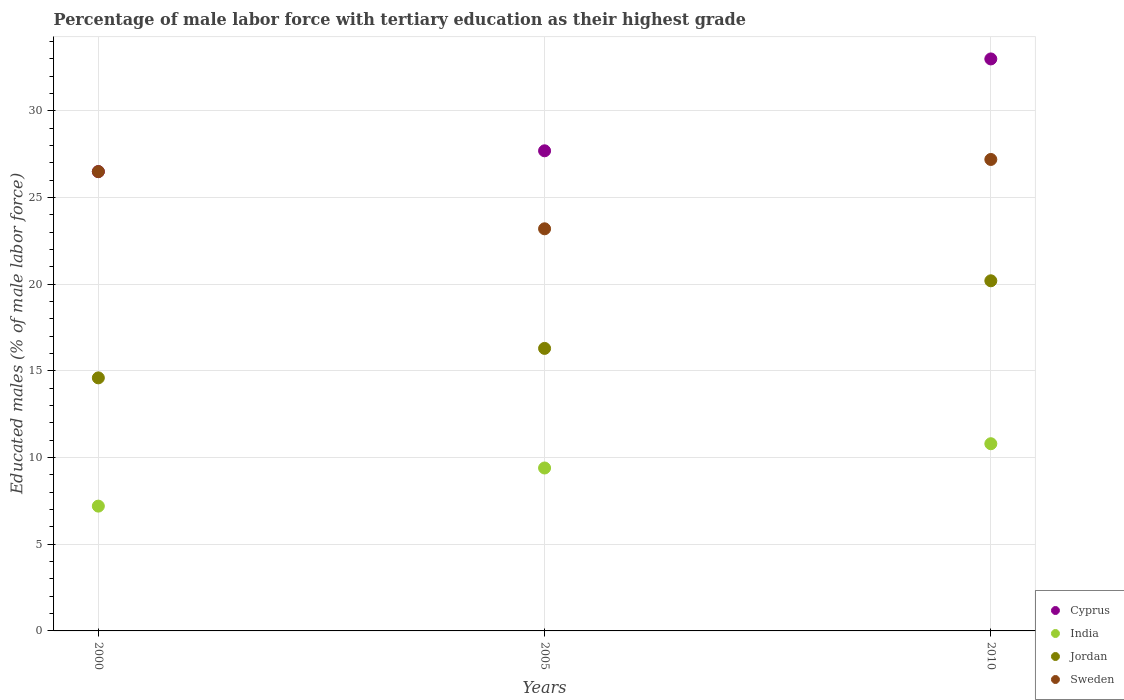Is the number of dotlines equal to the number of legend labels?
Your answer should be compact. Yes. What is the percentage of male labor force with tertiary education in Sweden in 2005?
Your response must be concise. 23.2. Across all years, what is the maximum percentage of male labor force with tertiary education in Jordan?
Provide a short and direct response. 20.2. Across all years, what is the minimum percentage of male labor force with tertiary education in Sweden?
Offer a terse response. 23.2. In which year was the percentage of male labor force with tertiary education in Sweden maximum?
Keep it short and to the point. 2010. In which year was the percentage of male labor force with tertiary education in Cyprus minimum?
Provide a short and direct response. 2000. What is the total percentage of male labor force with tertiary education in Cyprus in the graph?
Keep it short and to the point. 87.2. What is the difference between the percentage of male labor force with tertiary education in Sweden in 2000 and that in 2010?
Your answer should be compact. -0.7. What is the average percentage of male labor force with tertiary education in Cyprus per year?
Give a very brief answer. 29.07. In how many years, is the percentage of male labor force with tertiary education in India greater than 16 %?
Keep it short and to the point. 0. What is the ratio of the percentage of male labor force with tertiary education in Sweden in 2000 to that in 2010?
Your answer should be compact. 0.97. Is the percentage of male labor force with tertiary education in Cyprus in 2000 less than that in 2005?
Keep it short and to the point. Yes. Is the difference between the percentage of male labor force with tertiary education in Cyprus in 2000 and 2010 greater than the difference between the percentage of male labor force with tertiary education in Sweden in 2000 and 2010?
Your answer should be compact. No. What is the difference between the highest and the second highest percentage of male labor force with tertiary education in India?
Your answer should be compact. 1.4. In how many years, is the percentage of male labor force with tertiary education in Cyprus greater than the average percentage of male labor force with tertiary education in Cyprus taken over all years?
Provide a short and direct response. 1. Is it the case that in every year, the sum of the percentage of male labor force with tertiary education in India and percentage of male labor force with tertiary education in Cyprus  is greater than the sum of percentage of male labor force with tertiary education in Jordan and percentage of male labor force with tertiary education in Sweden?
Ensure brevity in your answer.  No. Is the percentage of male labor force with tertiary education in India strictly greater than the percentage of male labor force with tertiary education in Jordan over the years?
Offer a terse response. No. What is the difference between two consecutive major ticks on the Y-axis?
Offer a very short reply. 5. Are the values on the major ticks of Y-axis written in scientific E-notation?
Make the answer very short. No. Does the graph contain any zero values?
Your answer should be very brief. No. How many legend labels are there?
Ensure brevity in your answer.  4. How are the legend labels stacked?
Provide a short and direct response. Vertical. What is the title of the graph?
Ensure brevity in your answer.  Percentage of male labor force with tertiary education as their highest grade. What is the label or title of the Y-axis?
Ensure brevity in your answer.  Educated males (% of male labor force). What is the Educated males (% of male labor force) of India in 2000?
Keep it short and to the point. 7.2. What is the Educated males (% of male labor force) in Jordan in 2000?
Ensure brevity in your answer.  14.6. What is the Educated males (% of male labor force) of Sweden in 2000?
Provide a short and direct response. 26.5. What is the Educated males (% of male labor force) in Cyprus in 2005?
Offer a very short reply. 27.7. What is the Educated males (% of male labor force) in India in 2005?
Provide a short and direct response. 9.4. What is the Educated males (% of male labor force) of Jordan in 2005?
Your answer should be compact. 16.3. What is the Educated males (% of male labor force) of Sweden in 2005?
Your answer should be very brief. 23.2. What is the Educated males (% of male labor force) in India in 2010?
Your answer should be compact. 10.8. What is the Educated males (% of male labor force) of Jordan in 2010?
Make the answer very short. 20.2. What is the Educated males (% of male labor force) in Sweden in 2010?
Your response must be concise. 27.2. Across all years, what is the maximum Educated males (% of male labor force) of India?
Provide a succinct answer. 10.8. Across all years, what is the maximum Educated males (% of male labor force) of Jordan?
Provide a short and direct response. 20.2. Across all years, what is the maximum Educated males (% of male labor force) of Sweden?
Provide a short and direct response. 27.2. Across all years, what is the minimum Educated males (% of male labor force) of India?
Ensure brevity in your answer.  7.2. Across all years, what is the minimum Educated males (% of male labor force) of Jordan?
Offer a terse response. 14.6. Across all years, what is the minimum Educated males (% of male labor force) in Sweden?
Your response must be concise. 23.2. What is the total Educated males (% of male labor force) in Cyprus in the graph?
Keep it short and to the point. 87.2. What is the total Educated males (% of male labor force) of India in the graph?
Keep it short and to the point. 27.4. What is the total Educated males (% of male labor force) of Jordan in the graph?
Offer a terse response. 51.1. What is the total Educated males (% of male labor force) of Sweden in the graph?
Ensure brevity in your answer.  76.9. What is the difference between the Educated males (% of male labor force) of Cyprus in 2000 and that in 2005?
Your response must be concise. -1.2. What is the difference between the Educated males (% of male labor force) of Sweden in 2000 and that in 2005?
Offer a terse response. 3.3. What is the difference between the Educated males (% of male labor force) in India in 2000 and that in 2010?
Ensure brevity in your answer.  -3.6. What is the difference between the Educated males (% of male labor force) of Jordan in 2000 and that in 2010?
Provide a short and direct response. -5.6. What is the difference between the Educated males (% of male labor force) of Sweden in 2000 and that in 2010?
Give a very brief answer. -0.7. What is the difference between the Educated males (% of male labor force) in Cyprus in 2005 and that in 2010?
Give a very brief answer. -5.3. What is the difference between the Educated males (% of male labor force) of India in 2005 and that in 2010?
Your answer should be compact. -1.4. What is the difference between the Educated males (% of male labor force) of Jordan in 2005 and that in 2010?
Offer a very short reply. -3.9. What is the difference between the Educated males (% of male labor force) in Sweden in 2005 and that in 2010?
Offer a very short reply. -4. What is the difference between the Educated males (% of male labor force) of Cyprus in 2000 and the Educated males (% of male labor force) of Jordan in 2005?
Offer a very short reply. 10.2. What is the difference between the Educated males (% of male labor force) of Cyprus in 2000 and the Educated males (% of male labor force) of Sweden in 2005?
Offer a very short reply. 3.3. What is the difference between the Educated males (% of male labor force) of Cyprus in 2000 and the Educated males (% of male labor force) of Jordan in 2010?
Provide a short and direct response. 6.3. What is the difference between the Educated males (% of male labor force) in Cyprus in 2005 and the Educated males (% of male labor force) in India in 2010?
Provide a short and direct response. 16.9. What is the difference between the Educated males (% of male labor force) of India in 2005 and the Educated males (% of male labor force) of Jordan in 2010?
Provide a succinct answer. -10.8. What is the difference between the Educated males (% of male labor force) in India in 2005 and the Educated males (% of male labor force) in Sweden in 2010?
Give a very brief answer. -17.8. What is the average Educated males (% of male labor force) in Cyprus per year?
Your response must be concise. 29.07. What is the average Educated males (% of male labor force) of India per year?
Provide a short and direct response. 9.13. What is the average Educated males (% of male labor force) of Jordan per year?
Offer a very short reply. 17.03. What is the average Educated males (% of male labor force) in Sweden per year?
Offer a terse response. 25.63. In the year 2000, what is the difference between the Educated males (% of male labor force) in Cyprus and Educated males (% of male labor force) in India?
Keep it short and to the point. 19.3. In the year 2000, what is the difference between the Educated males (% of male labor force) of India and Educated males (% of male labor force) of Sweden?
Your response must be concise. -19.3. In the year 2000, what is the difference between the Educated males (% of male labor force) of Jordan and Educated males (% of male labor force) of Sweden?
Your answer should be very brief. -11.9. In the year 2005, what is the difference between the Educated males (% of male labor force) of Cyprus and Educated males (% of male labor force) of India?
Your response must be concise. 18.3. In the year 2005, what is the difference between the Educated males (% of male labor force) of India and Educated males (% of male labor force) of Sweden?
Offer a terse response. -13.8. In the year 2005, what is the difference between the Educated males (% of male labor force) of Jordan and Educated males (% of male labor force) of Sweden?
Offer a terse response. -6.9. In the year 2010, what is the difference between the Educated males (% of male labor force) of India and Educated males (% of male labor force) of Jordan?
Your answer should be very brief. -9.4. In the year 2010, what is the difference between the Educated males (% of male labor force) of India and Educated males (% of male labor force) of Sweden?
Offer a very short reply. -16.4. What is the ratio of the Educated males (% of male labor force) in Cyprus in 2000 to that in 2005?
Make the answer very short. 0.96. What is the ratio of the Educated males (% of male labor force) of India in 2000 to that in 2005?
Offer a terse response. 0.77. What is the ratio of the Educated males (% of male labor force) of Jordan in 2000 to that in 2005?
Make the answer very short. 0.9. What is the ratio of the Educated males (% of male labor force) in Sweden in 2000 to that in 2005?
Provide a succinct answer. 1.14. What is the ratio of the Educated males (% of male labor force) in Cyprus in 2000 to that in 2010?
Make the answer very short. 0.8. What is the ratio of the Educated males (% of male labor force) in Jordan in 2000 to that in 2010?
Your answer should be compact. 0.72. What is the ratio of the Educated males (% of male labor force) in Sweden in 2000 to that in 2010?
Offer a terse response. 0.97. What is the ratio of the Educated males (% of male labor force) of Cyprus in 2005 to that in 2010?
Give a very brief answer. 0.84. What is the ratio of the Educated males (% of male labor force) of India in 2005 to that in 2010?
Keep it short and to the point. 0.87. What is the ratio of the Educated males (% of male labor force) in Jordan in 2005 to that in 2010?
Provide a succinct answer. 0.81. What is the ratio of the Educated males (% of male labor force) in Sweden in 2005 to that in 2010?
Make the answer very short. 0.85. What is the difference between the highest and the second highest Educated males (% of male labor force) in Cyprus?
Give a very brief answer. 5.3. What is the difference between the highest and the second highest Educated males (% of male labor force) of India?
Provide a short and direct response. 1.4. What is the difference between the highest and the second highest Educated males (% of male labor force) in Jordan?
Make the answer very short. 3.9. What is the difference between the highest and the second highest Educated males (% of male labor force) of Sweden?
Make the answer very short. 0.7. What is the difference between the highest and the lowest Educated males (% of male labor force) of Cyprus?
Keep it short and to the point. 6.5. What is the difference between the highest and the lowest Educated males (% of male labor force) in India?
Give a very brief answer. 3.6. What is the difference between the highest and the lowest Educated males (% of male labor force) of Jordan?
Offer a very short reply. 5.6. 